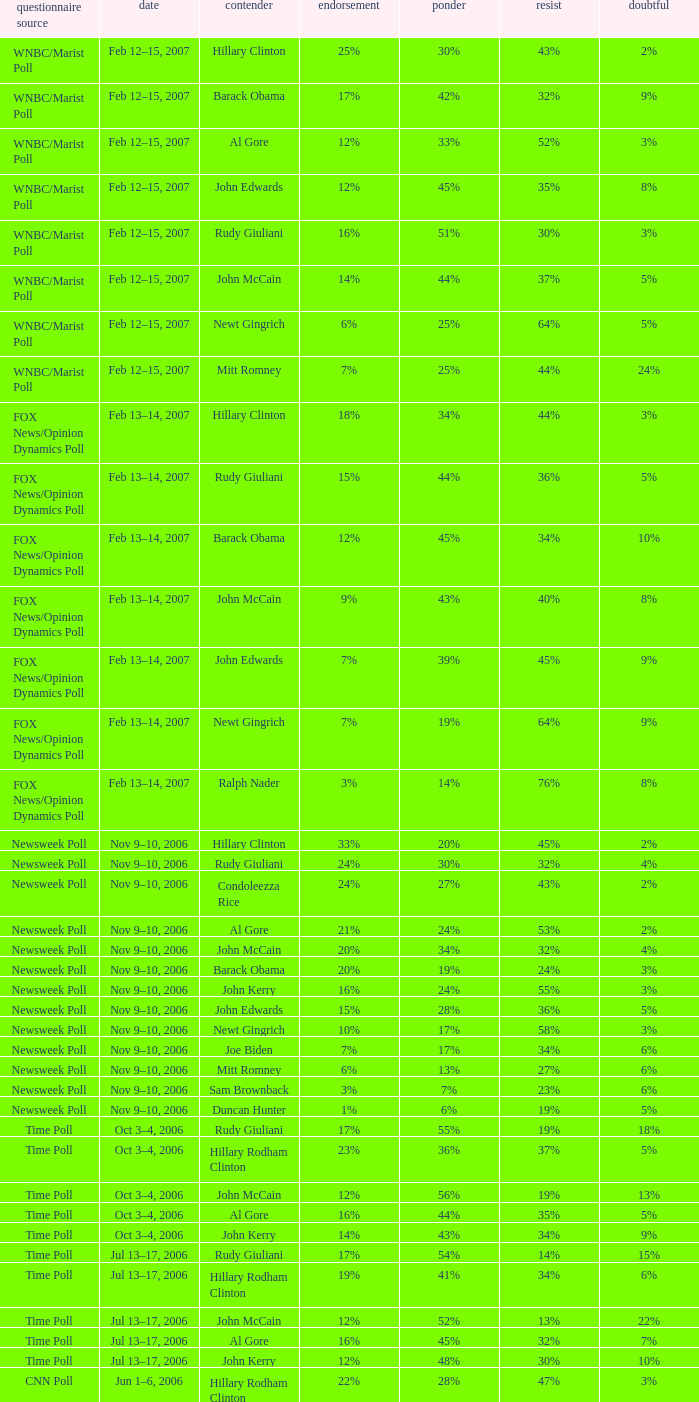What percentage of people were opposed to the candidate based on the WNBC/Marist poll that showed 8% of people were unsure? 35%. 